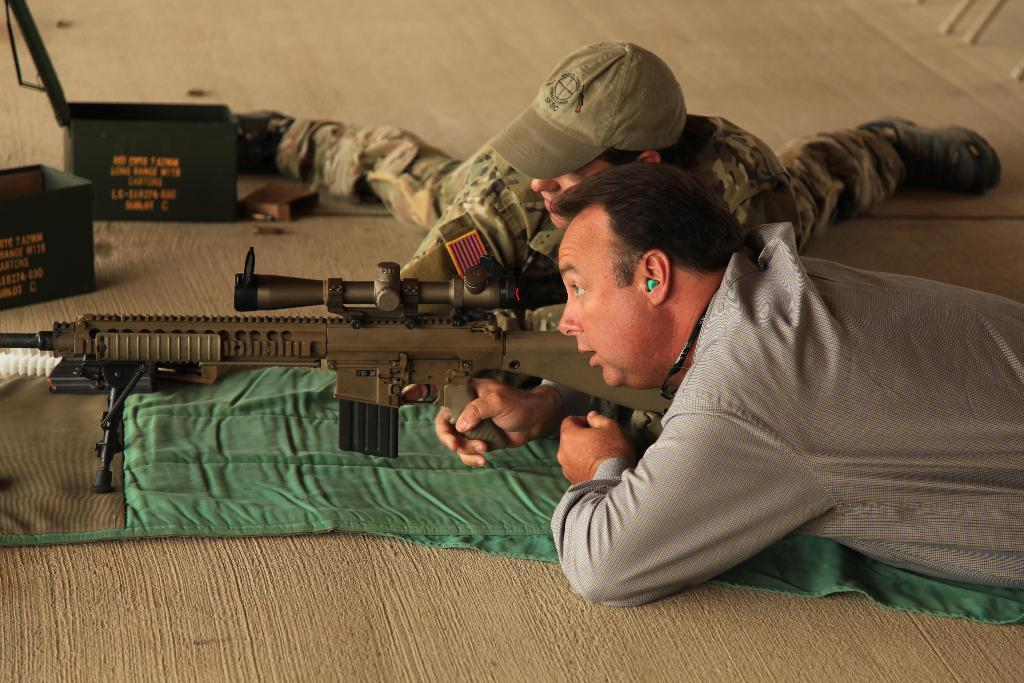Who or what is present in the image? There are people in the image. What are the people doing in the image? The people are lying down. What objects are the people holding in the image? The people are holding guns. How many goldfish can be seen swimming in the image? There are no goldfish present in the image. What type of mice are visible in the image? There are no mice present in the image. 